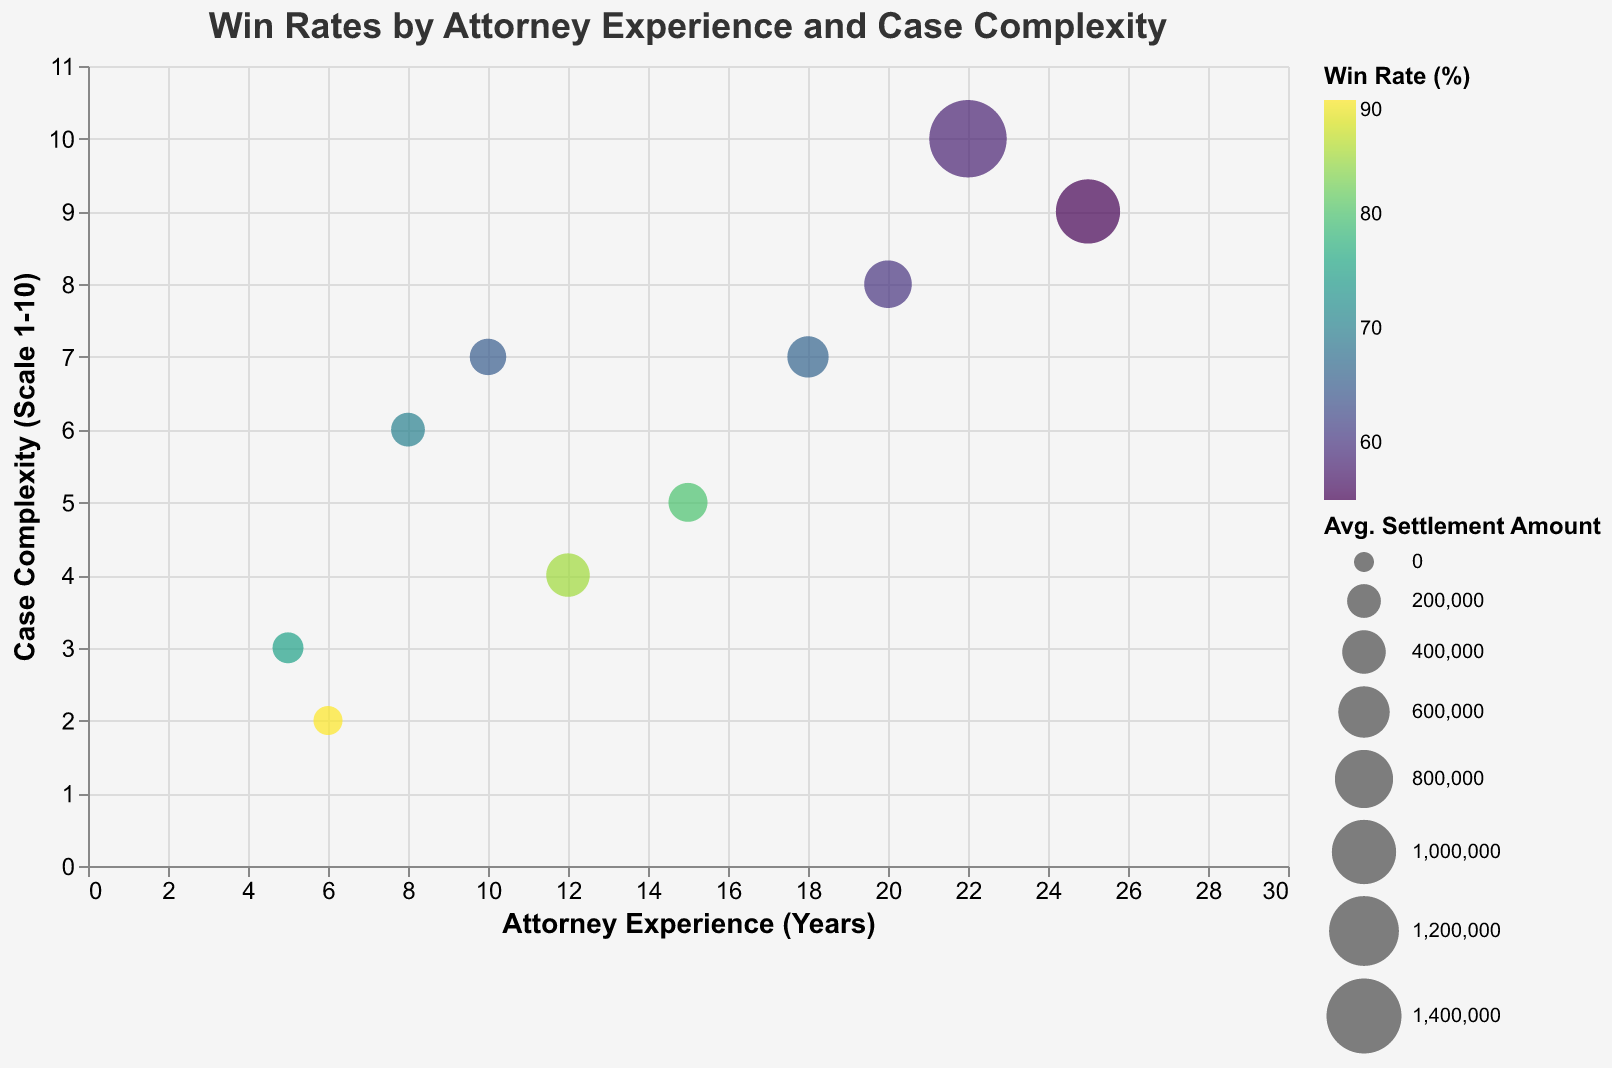What is the title of the chart? The chart's title is at the top, written in a font size of 18 and is "Win Rates by Attorney Experience and Case Complexity".
Answer: Win Rates by Attorney Experience and Case Complexity How many data points are plotted on the bubble chart? By counting the bubbles (or data points) in the chart, you can see there are 10 data points.
Answer: 10 Which attorney has the highest win rate and what is it? By examining the bubbles on the chart that represent win rates, the bubble with the highest win rate percentage belongs to Patricia Thomas with a win rate of 90%.
Answer: Patricia Thomas, 90% Which attorney handles the most complex cases (highest complexity score) and what is the score? The attorney handling the most complex cases would appear on the far-right side of the chart along the y-axis. Brian Anderson handles cases with a complexity score of 10.
Answer: Brian Anderson, 10 Which attorney has the largest average settlement amount, and what is that amount? By examining the sizes of the bubbles, the largest bubble represents an attorney with the highest average settlement amount. This is David Wilson with an average settlement amount of $1,000,000.
Answer: David Wilson, $1,000,000 How does experience correlate with win rate for attorneys dealing with medium complexity cases (complexity score of 7)? Identifying the bubbles corresponding to a complexity score of 7 (Jane Doe and Laura Taylor), you can compare their experience (10 and 18 years) and win rates (65% and 66%). Experience does not significantly change the win rate between these two attorneys.
Answer: Slight increase What is the difference in win rate between the most and least experienced attorneys? David Wilson is the most experienced attorney with 25 years and a win rate of 55%, while John Smith is one of the least experienced attorneys with 5 years and a win rate of 75%. The difference is 75% - 55% = 20%.
Answer: 20% Which attorney has the lowest win rate and what is their average settlement amount? By locating the bubble with the lowest color intensity for win rates, Emily Davis is identified with a win rate of 60% and an average settlement amount of $500,000.
Answer: Emily Davis, $500,000 Is there any attorney who has high win rates despite handling complex cases (complexity score 6 or above)? Jessica Miller handles cases with a complexity score of 6 and has a win rate of 70%.
Answer: Yes, Jessica Miller 